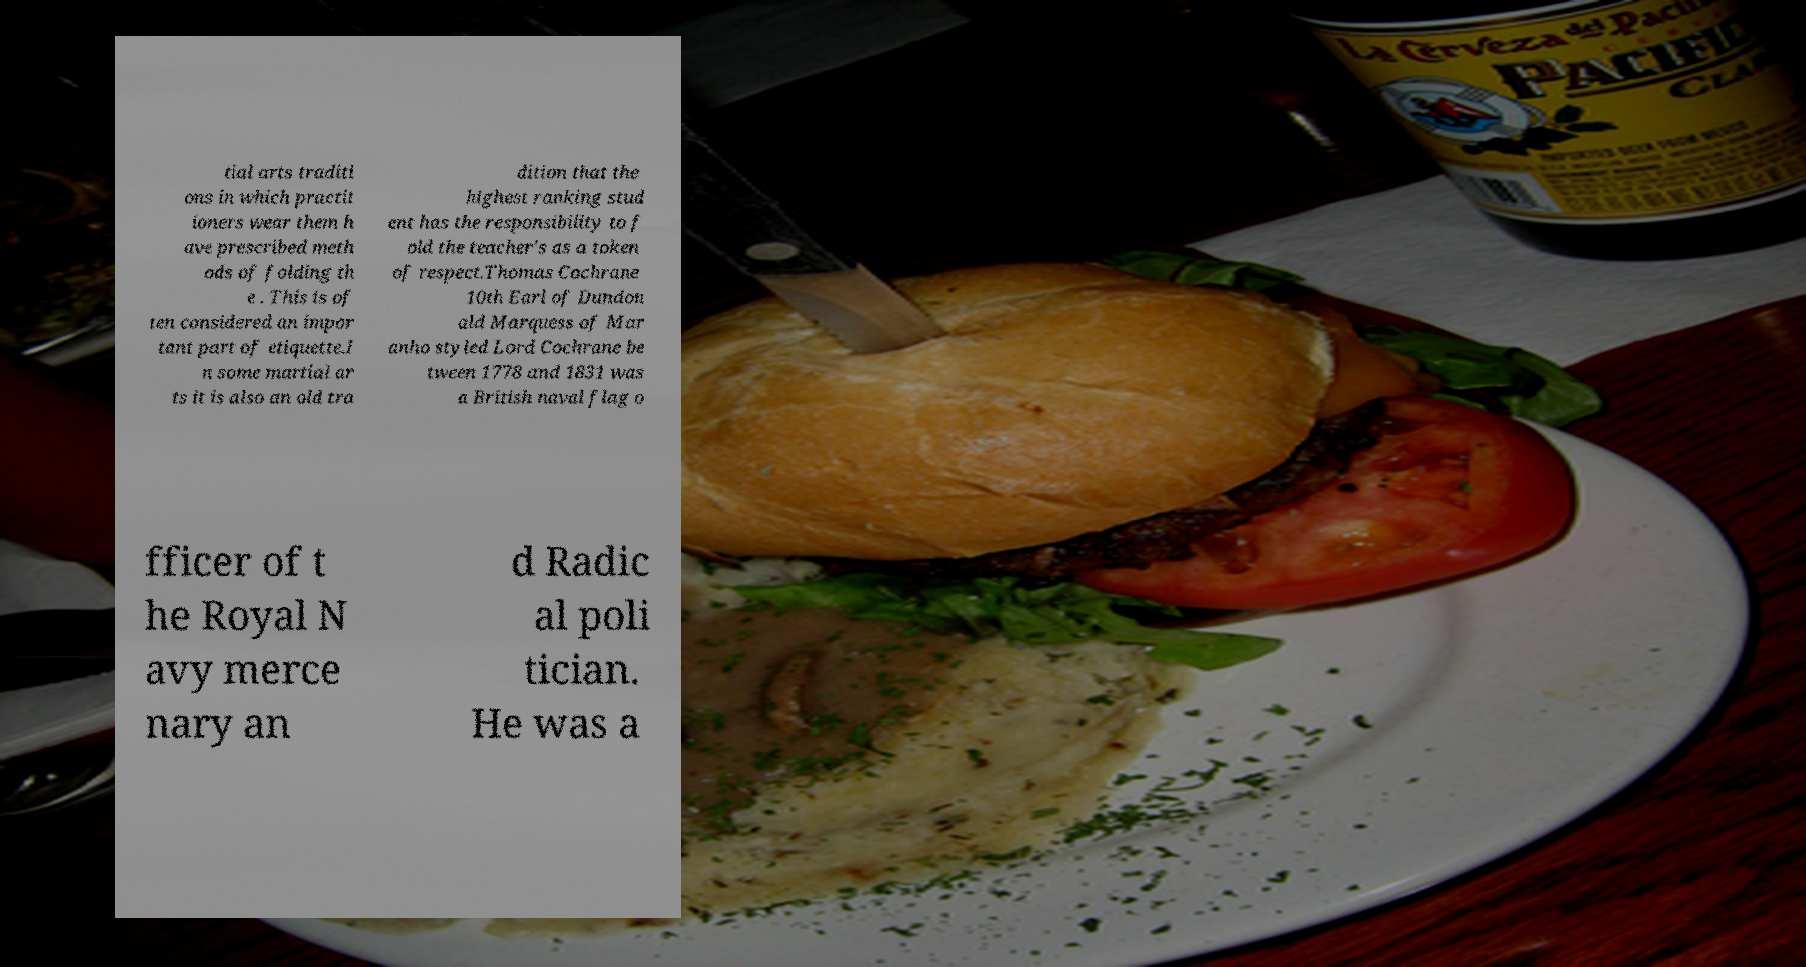Can you read and provide the text displayed in the image?This photo seems to have some interesting text. Can you extract and type it out for me? tial arts traditi ons in which practit ioners wear them h ave prescribed meth ods of folding th e . This is of ten considered an impor tant part of etiquette.I n some martial ar ts it is also an old tra dition that the highest ranking stud ent has the responsibility to f old the teacher's as a token of respect.Thomas Cochrane 10th Earl of Dundon ald Marquess of Mar anho styled Lord Cochrane be tween 1778 and 1831 was a British naval flag o fficer of t he Royal N avy merce nary an d Radic al poli tician. He was a 